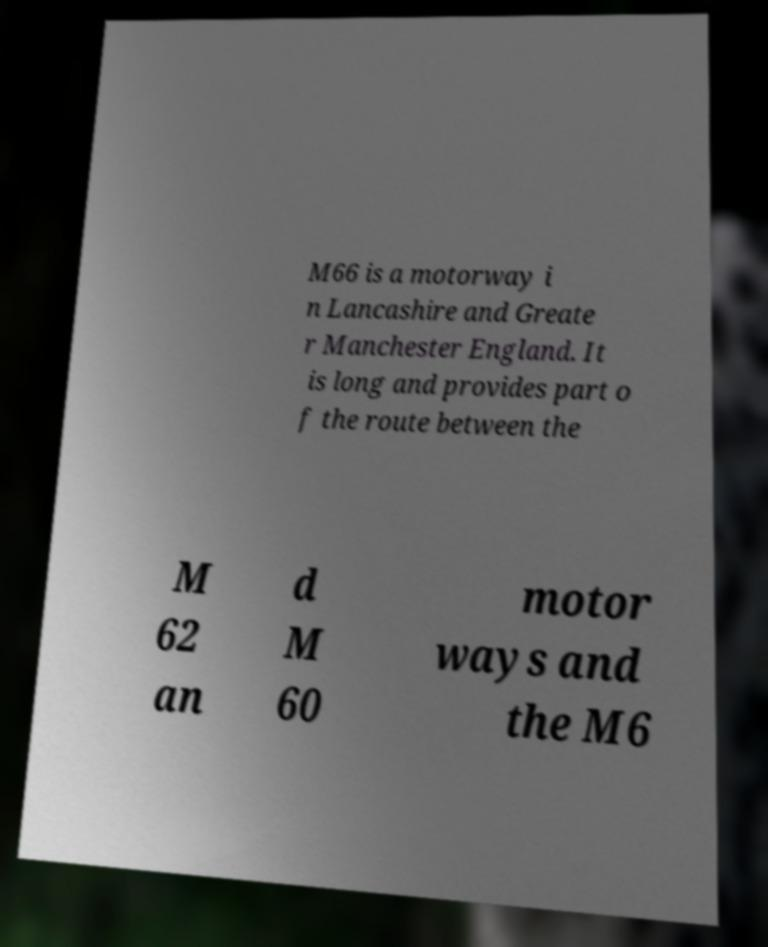For documentation purposes, I need the text within this image transcribed. Could you provide that? M66 is a motorway i n Lancashire and Greate r Manchester England. It is long and provides part o f the route between the M 62 an d M 60 motor ways and the M6 